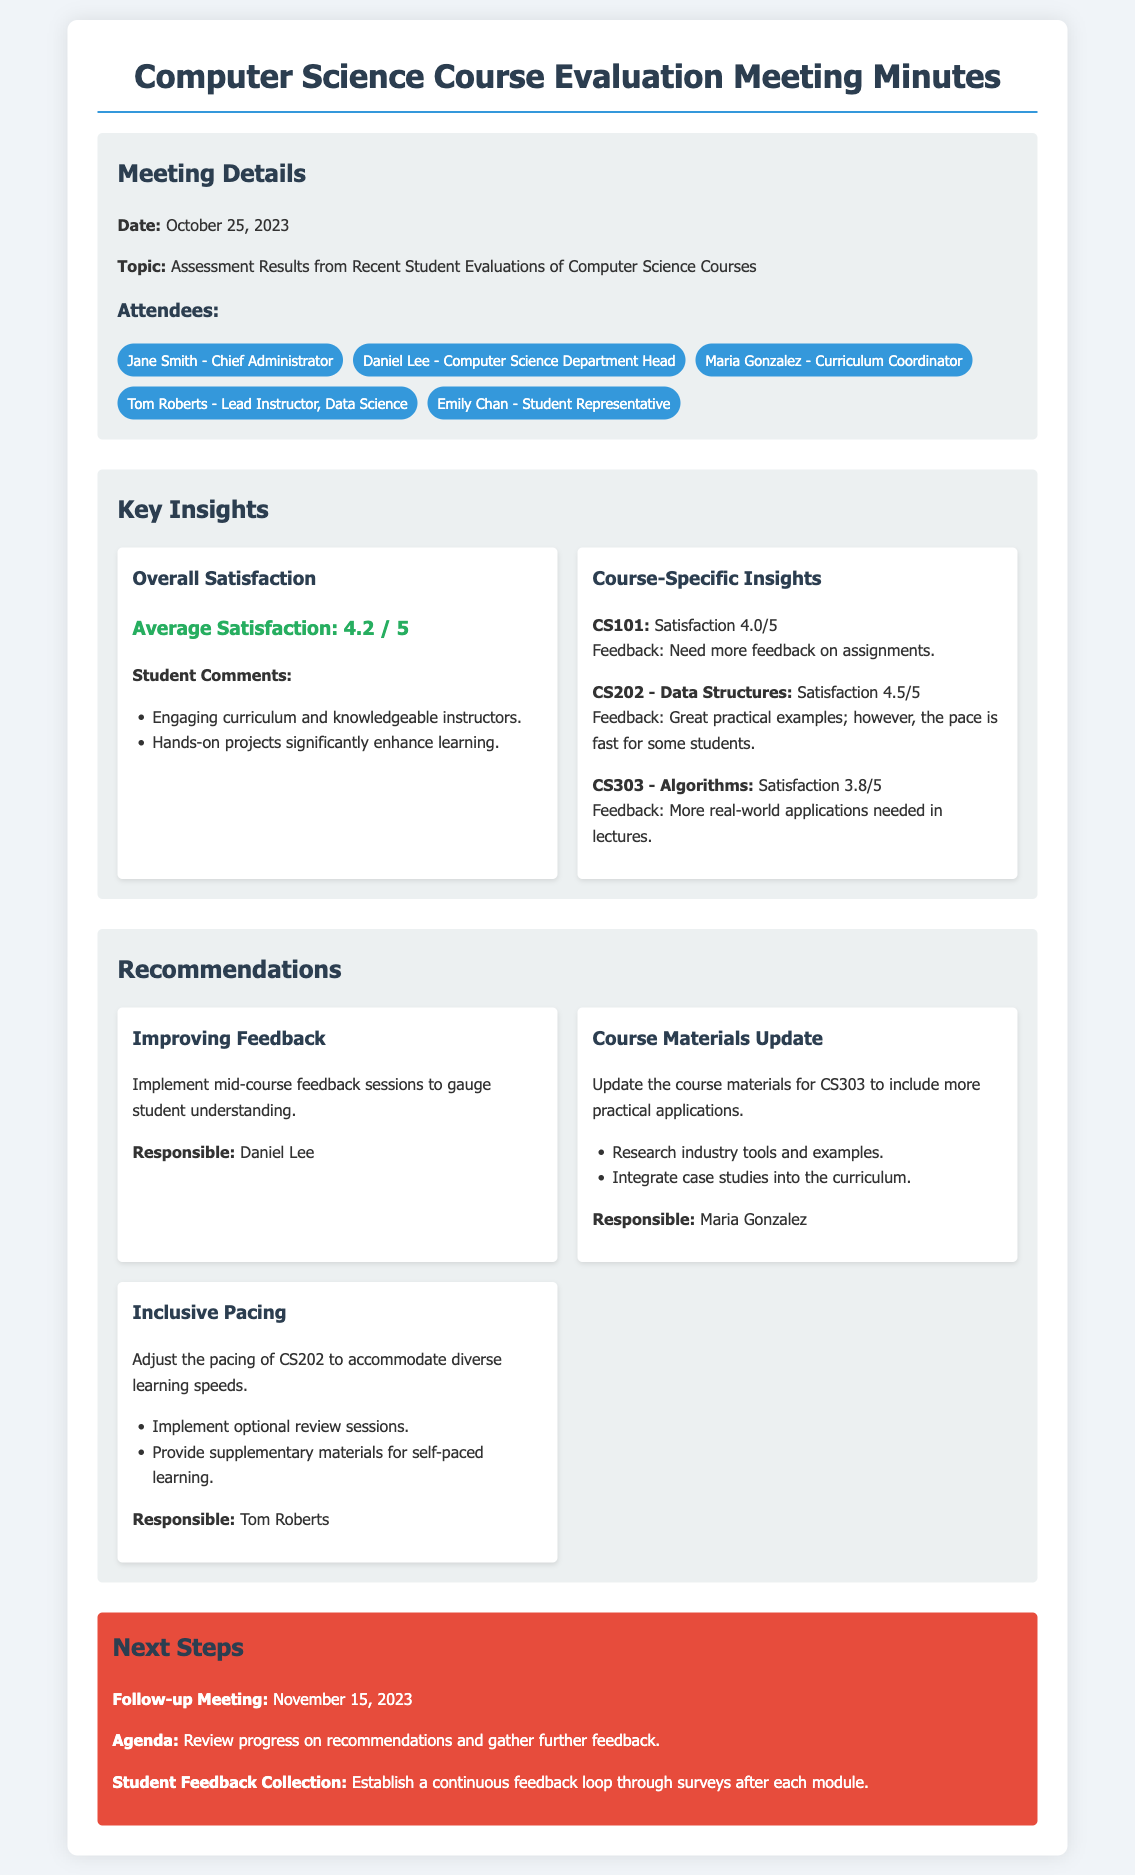What was the average satisfaction score? The average satisfaction score can be found in the "Overall Satisfaction" section, which states 4.2 out of 5.
Answer: 4.2 / 5 Who was responsible for updating course materials for CS303? In the "Recommendations" section, Maria Gonzalez is mentioned as responsible for updating course materials.
Answer: Maria Gonzalez What date is the follow-up meeting scheduled for? The follow-up meeting date is listed in the "Next Steps" section as November 15, 2023.
Answer: November 15, 2023 Which course had the lowest satisfaction score? The satisfaction scores for the courses indicate that CS303 had the lowest score at 3.8.
Answer: CS303 What specific recommendation was made for CS202? An adjustment in pacing was recommended for CS202 to accommodate diverse learning speeds.
Answer: Adjust the pacing of CS202 What is one reason students gave for their satisfaction with instructors? Students commented on the engaging curriculum and knowledgeable instructors, indicating they found these aspects satisfying.
Answer: Knowledgeable instructors How many attendees were present at the meeting? The document lists five attendees in the "Attendees" section.
Answer: Five What is one of the next steps regarding student feedback? The next step involves establishing a continuous feedback loop through surveys after each module.
Answer: Continuous feedback loop through surveys What feedback did students provide about CS101? Students requested more feedback on assignments for CS101, as noted in the "Course-Specific Insights" section.
Answer: Need more feedback on assignments 